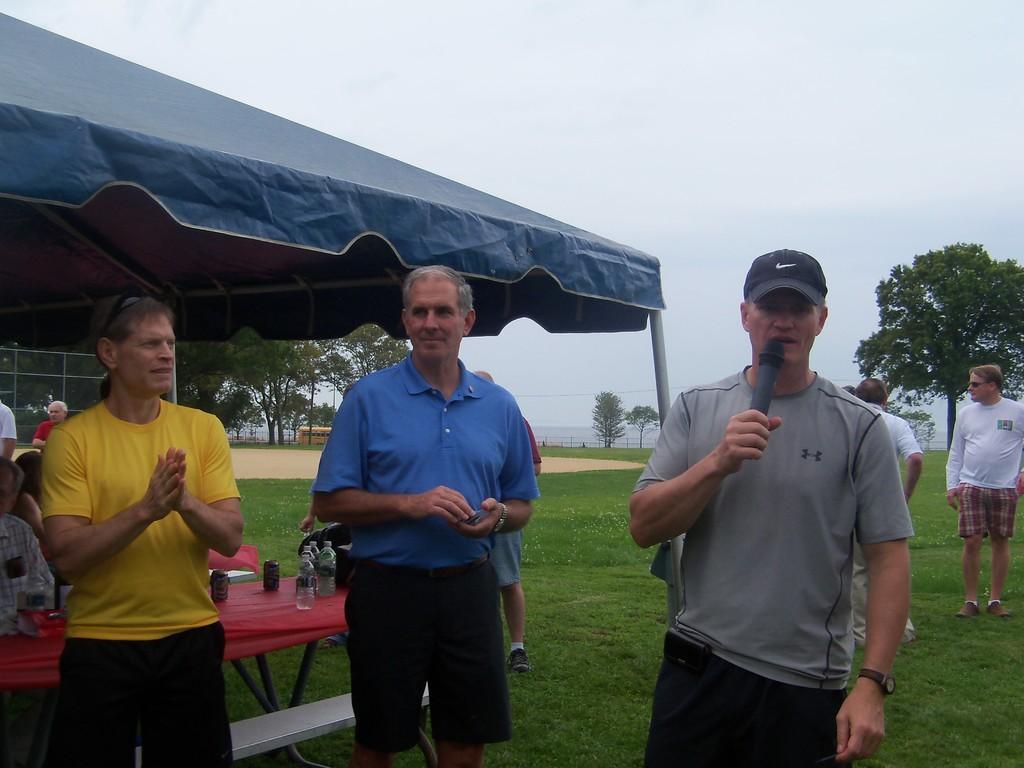Describe this image in one or two sentences. As we can see in the image there are few people here and there, grass, tables and trees. On table there are bottles. On the top there is sky. 